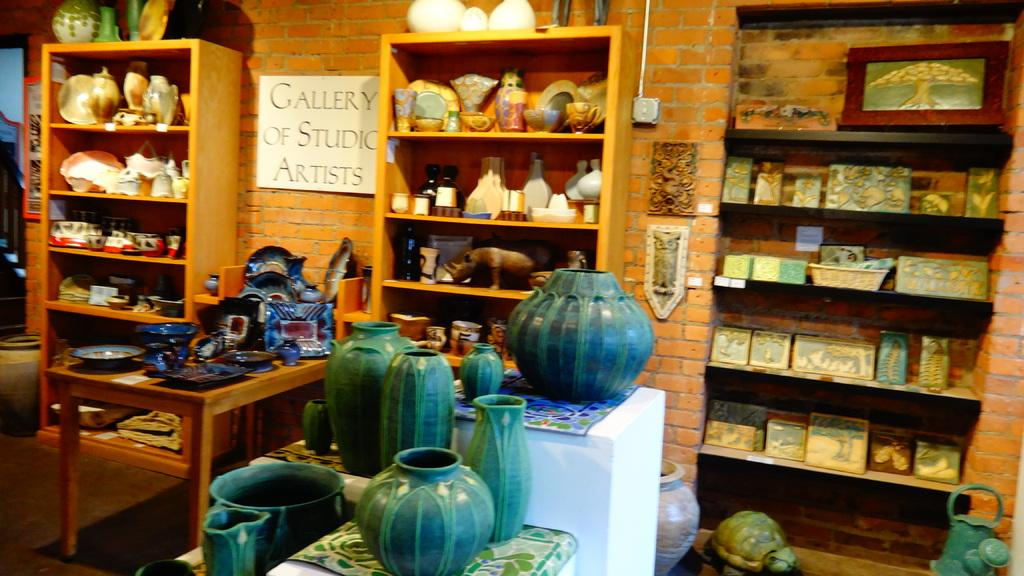<image>
Create a compact narrative representing the image presented. A shop featuring ceramics with a sign that says Gallery of Studio Artists. 